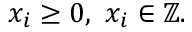Convert formula to latex. <formula><loc_0><loc_0><loc_500><loc_500>x _ { i } \geq 0 , \ x _ { i } \in \mathbb { Z } .</formula> 